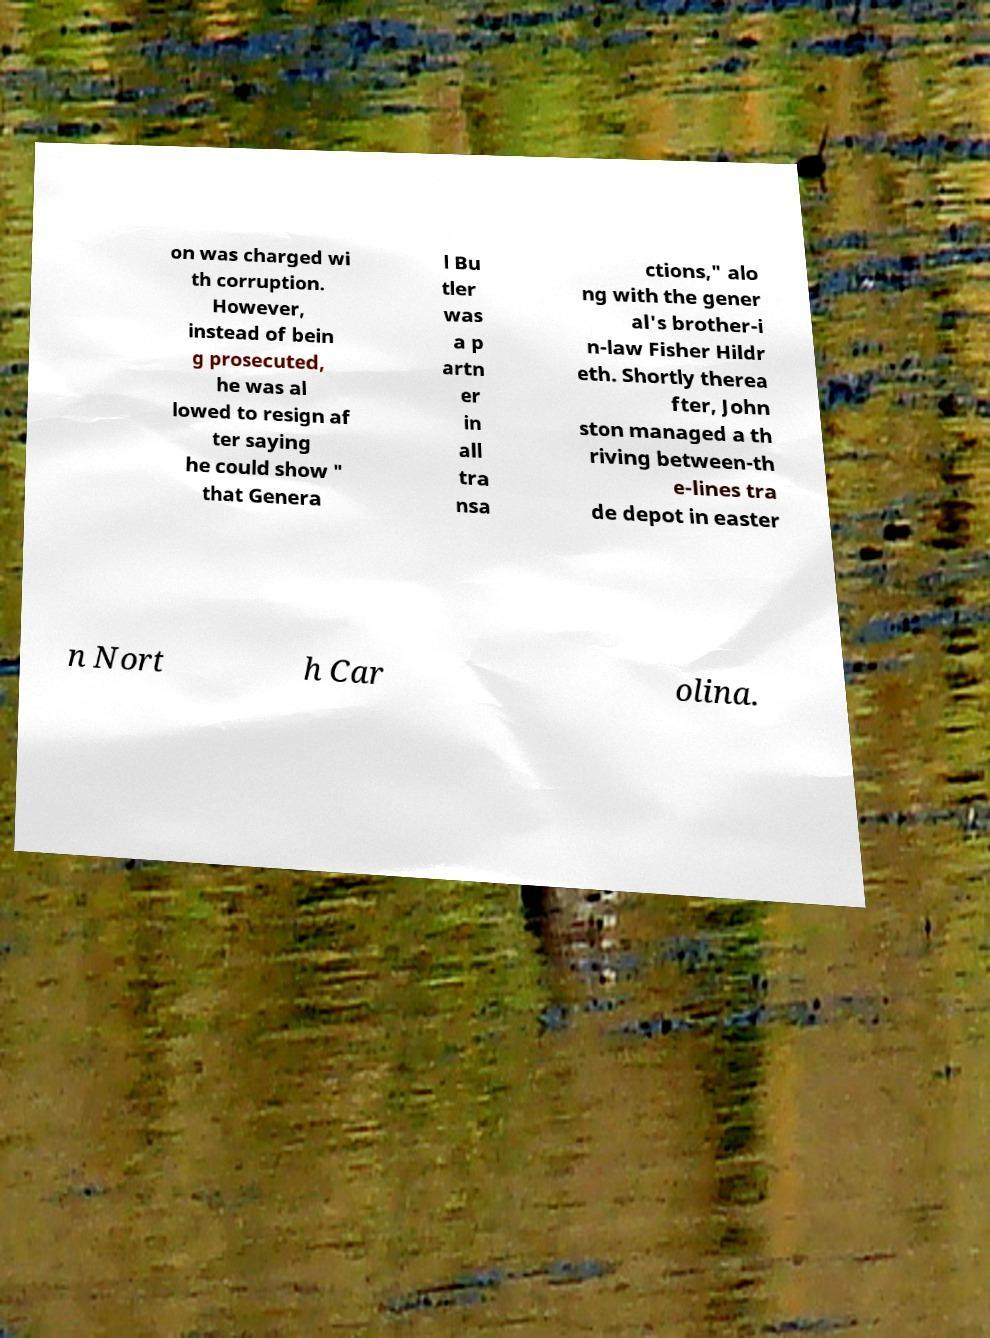Please read and relay the text visible in this image. What does it say? on was charged wi th corruption. However, instead of bein g prosecuted, he was al lowed to resign af ter saying he could show " that Genera l Bu tler was a p artn er in all tra nsa ctions," alo ng with the gener al's brother-i n-law Fisher Hildr eth. Shortly therea fter, John ston managed a th riving between-th e-lines tra de depot in easter n Nort h Car olina. 